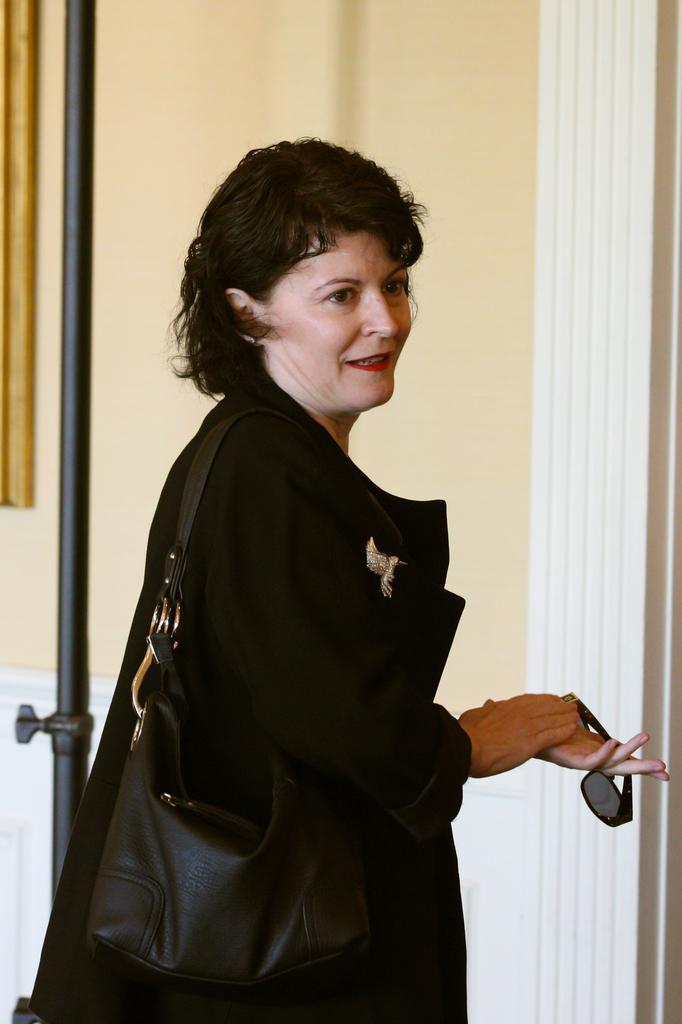In one or two sentences, can you explain what this image depicts? There is a woman in the given picture holding a bag on her Shoulders. She is having spectacles in her hand. She is wearing a black dress and she smiling. In the background there is a wall here. 